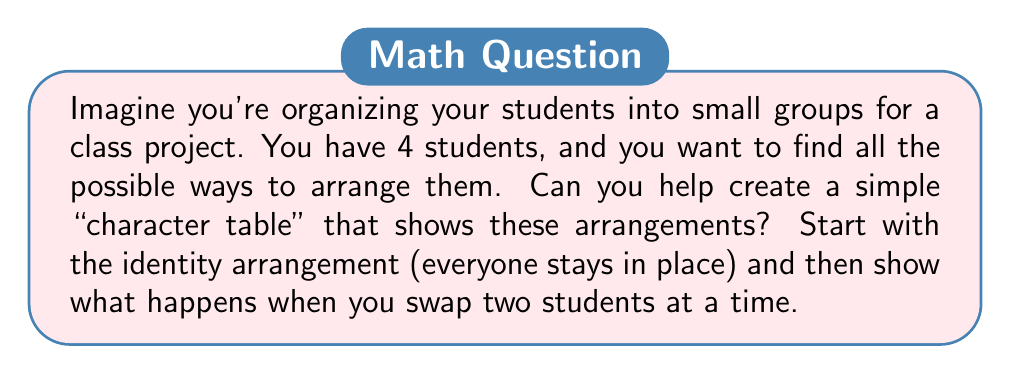Can you answer this question? Let's approach this step-by-step:

1) First, we need to understand what a character table is. In this simplified context, it's a table that shows how different arrangements (permutations) of our 4 students affect the group.

2) We'll label our students A, B, C, and D.

3) The possible arrangements (elements of our group) are:
   - Identity (e): (A,B,C,D) - everyone stays in place
   - (AB): swap A and B
   - (AC): swap A and C
   - (AD): swap A and D
   - (BC): swap B and C
   - (BD): swap B and D
   - (CD): swap C and D

4) Now, we'll create our character table. The rows represent our "characters" (in this case, we'll use the students themselves), and the columns represent our group elements.

5) For each cell, we'll put a 1 if the student is unmoved by the permutation, and a -1 if they are moved.

6) Our character table will look like this:

   $$
   \begin{array}{c|ccccccc}
     & e & (AB) & (AC) & (AD) & (BC) & (BD) & (CD) \\
   \hline
   A & 1 & -1 & -1 & -1 & 1 & 1 & 1 \\
   B & 1 & -1 & 1 & 1 & -1 & -1 & 1 \\
   C & 1 & 1 & -1 & 1 & -1 & 1 & -1 \\
   D & 1 & 1 & 1 & -1 & 1 & -1 & -1
   \end{array}
   $$

This simplified character table shows how each arrangement affects each student. For example, in the (AB) column, A and B have -1 because they're swapped, while C and D have 1 because they stay in place.
Answer: $$
\begin{array}{c|ccccccc}
 & e & (AB) & (AC) & (AD) & (BC) & (BD) & (CD) \\
\hline
A & 1 & -1 & -1 & -1 & 1 & 1 & 1 \\
B & 1 & -1 & 1 & 1 & -1 & -1 & 1 \\
C & 1 & 1 & -1 & 1 & -1 & 1 & -1 \\
D & 1 & 1 & 1 & -1 & 1 & -1 & -1
\end{array}
$$ 